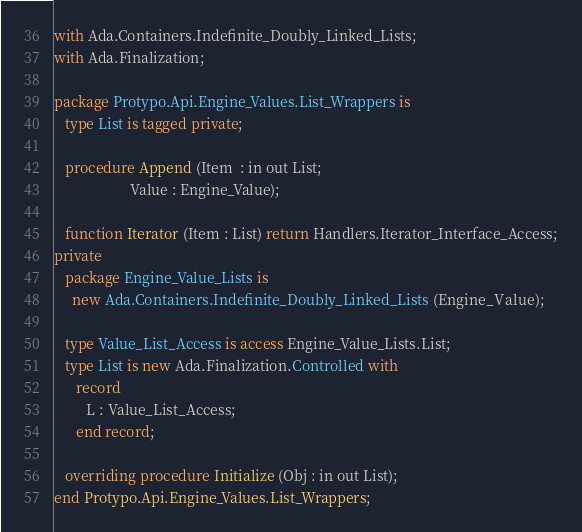Convert code to text. <code><loc_0><loc_0><loc_500><loc_500><_Ada_>with Ada.Containers.Indefinite_Doubly_Linked_Lists;
with Ada.Finalization;

package Protypo.Api.Engine_Values.List_Wrappers is
   type List is tagged private;

   procedure Append (Item  : in out List;
                     Value : Engine_Value);

   function Iterator (Item : List) return Handlers.Iterator_Interface_Access;
private
   package Engine_Value_Lists is
     new Ada.Containers.Indefinite_Doubly_Linked_Lists (Engine_Value);

   type Value_List_Access is access Engine_Value_Lists.List;
   type List is new Ada.Finalization.Controlled with
      record
         L : Value_List_Access;
      end record;

   overriding procedure Initialize (Obj : in out List);
end Protypo.Api.Engine_Values.List_Wrappers;
</code> 